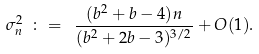<formula> <loc_0><loc_0><loc_500><loc_500>\sigma _ { n } ^ { 2 } \ \colon = \ \frac { ( b ^ { 2 } + b - 4 ) n } { ( b ^ { 2 } + 2 b - 3 ) ^ { 3 / 2 } } + O ( 1 ) .</formula> 